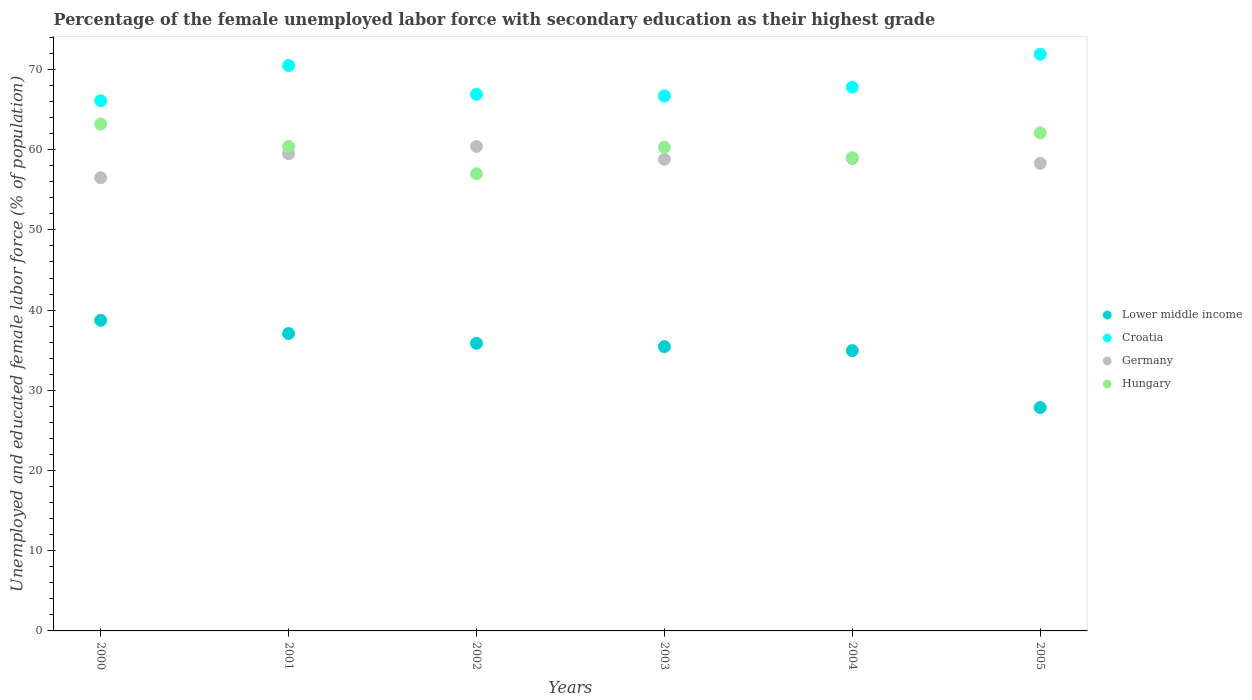How many different coloured dotlines are there?
Your answer should be very brief. 4. Is the number of dotlines equal to the number of legend labels?
Give a very brief answer. Yes. What is the percentage of the unemployed female labor force with secondary education in Hungary in 2002?
Ensure brevity in your answer.  57. Across all years, what is the maximum percentage of the unemployed female labor force with secondary education in Croatia?
Keep it short and to the point. 71.9. Across all years, what is the minimum percentage of the unemployed female labor force with secondary education in Lower middle income?
Your response must be concise. 27.85. What is the total percentage of the unemployed female labor force with secondary education in Germany in the graph?
Your answer should be compact. 352.4. What is the difference between the percentage of the unemployed female labor force with secondary education in Germany in 2001 and that in 2003?
Make the answer very short. 0.7. What is the difference between the percentage of the unemployed female labor force with secondary education in Lower middle income in 2004 and the percentage of the unemployed female labor force with secondary education in Germany in 2002?
Make the answer very short. -25.45. What is the average percentage of the unemployed female labor force with secondary education in Germany per year?
Ensure brevity in your answer.  58.73. In the year 2005, what is the difference between the percentage of the unemployed female labor force with secondary education in Croatia and percentage of the unemployed female labor force with secondary education in Germany?
Your response must be concise. 13.6. What is the ratio of the percentage of the unemployed female labor force with secondary education in Germany in 2001 to that in 2003?
Offer a terse response. 1.01. Is the difference between the percentage of the unemployed female labor force with secondary education in Croatia in 2003 and 2005 greater than the difference between the percentage of the unemployed female labor force with secondary education in Germany in 2003 and 2005?
Ensure brevity in your answer.  No. What is the difference between the highest and the second highest percentage of the unemployed female labor force with secondary education in Lower middle income?
Your answer should be compact. 1.64. What is the difference between the highest and the lowest percentage of the unemployed female labor force with secondary education in Lower middle income?
Provide a short and direct response. 10.87. Is the sum of the percentage of the unemployed female labor force with secondary education in Croatia in 2001 and 2005 greater than the maximum percentage of the unemployed female labor force with secondary education in Hungary across all years?
Your response must be concise. Yes. Is it the case that in every year, the sum of the percentage of the unemployed female labor force with secondary education in Lower middle income and percentage of the unemployed female labor force with secondary education in Germany  is greater than the sum of percentage of the unemployed female labor force with secondary education in Croatia and percentage of the unemployed female labor force with secondary education in Hungary?
Ensure brevity in your answer.  No. Is it the case that in every year, the sum of the percentage of the unemployed female labor force with secondary education in Hungary and percentage of the unemployed female labor force with secondary education in Germany  is greater than the percentage of the unemployed female labor force with secondary education in Croatia?
Offer a terse response. Yes. Does the percentage of the unemployed female labor force with secondary education in Germany monotonically increase over the years?
Provide a succinct answer. No. Is the percentage of the unemployed female labor force with secondary education in Hungary strictly less than the percentage of the unemployed female labor force with secondary education in Lower middle income over the years?
Your response must be concise. No. How many dotlines are there?
Keep it short and to the point. 4. How many years are there in the graph?
Keep it short and to the point. 6. Are the values on the major ticks of Y-axis written in scientific E-notation?
Your answer should be very brief. No. Does the graph contain grids?
Provide a succinct answer. No. What is the title of the graph?
Your answer should be very brief. Percentage of the female unemployed labor force with secondary education as their highest grade. What is the label or title of the Y-axis?
Your response must be concise. Unemployed and educated female labor force (% of population). What is the Unemployed and educated female labor force (% of population) in Lower middle income in 2000?
Provide a short and direct response. 38.72. What is the Unemployed and educated female labor force (% of population) in Croatia in 2000?
Your answer should be very brief. 66.1. What is the Unemployed and educated female labor force (% of population) in Germany in 2000?
Provide a succinct answer. 56.5. What is the Unemployed and educated female labor force (% of population) of Hungary in 2000?
Give a very brief answer. 63.2. What is the Unemployed and educated female labor force (% of population) in Lower middle income in 2001?
Keep it short and to the point. 37.08. What is the Unemployed and educated female labor force (% of population) of Croatia in 2001?
Ensure brevity in your answer.  70.5. What is the Unemployed and educated female labor force (% of population) of Germany in 2001?
Provide a succinct answer. 59.5. What is the Unemployed and educated female labor force (% of population) of Hungary in 2001?
Give a very brief answer. 60.4. What is the Unemployed and educated female labor force (% of population) of Lower middle income in 2002?
Your answer should be compact. 35.86. What is the Unemployed and educated female labor force (% of population) in Croatia in 2002?
Keep it short and to the point. 66.9. What is the Unemployed and educated female labor force (% of population) of Germany in 2002?
Keep it short and to the point. 60.4. What is the Unemployed and educated female labor force (% of population) of Lower middle income in 2003?
Provide a short and direct response. 35.45. What is the Unemployed and educated female labor force (% of population) of Croatia in 2003?
Your answer should be compact. 66.7. What is the Unemployed and educated female labor force (% of population) of Germany in 2003?
Your answer should be very brief. 58.8. What is the Unemployed and educated female labor force (% of population) of Hungary in 2003?
Your answer should be compact. 60.3. What is the Unemployed and educated female labor force (% of population) of Lower middle income in 2004?
Provide a short and direct response. 34.95. What is the Unemployed and educated female labor force (% of population) in Croatia in 2004?
Ensure brevity in your answer.  67.8. What is the Unemployed and educated female labor force (% of population) of Germany in 2004?
Provide a short and direct response. 58.9. What is the Unemployed and educated female labor force (% of population) in Hungary in 2004?
Your answer should be compact. 59. What is the Unemployed and educated female labor force (% of population) of Lower middle income in 2005?
Offer a very short reply. 27.85. What is the Unemployed and educated female labor force (% of population) in Croatia in 2005?
Offer a terse response. 71.9. What is the Unemployed and educated female labor force (% of population) of Germany in 2005?
Your answer should be compact. 58.3. What is the Unemployed and educated female labor force (% of population) of Hungary in 2005?
Ensure brevity in your answer.  62.1. Across all years, what is the maximum Unemployed and educated female labor force (% of population) of Lower middle income?
Provide a short and direct response. 38.72. Across all years, what is the maximum Unemployed and educated female labor force (% of population) of Croatia?
Your answer should be very brief. 71.9. Across all years, what is the maximum Unemployed and educated female labor force (% of population) in Germany?
Offer a terse response. 60.4. Across all years, what is the maximum Unemployed and educated female labor force (% of population) of Hungary?
Provide a short and direct response. 63.2. Across all years, what is the minimum Unemployed and educated female labor force (% of population) in Lower middle income?
Offer a very short reply. 27.85. Across all years, what is the minimum Unemployed and educated female labor force (% of population) in Croatia?
Your response must be concise. 66.1. Across all years, what is the minimum Unemployed and educated female labor force (% of population) in Germany?
Ensure brevity in your answer.  56.5. Across all years, what is the minimum Unemployed and educated female labor force (% of population) in Hungary?
Give a very brief answer. 57. What is the total Unemployed and educated female labor force (% of population) of Lower middle income in the graph?
Your answer should be very brief. 209.91. What is the total Unemployed and educated female labor force (% of population) of Croatia in the graph?
Your answer should be very brief. 409.9. What is the total Unemployed and educated female labor force (% of population) in Germany in the graph?
Keep it short and to the point. 352.4. What is the total Unemployed and educated female labor force (% of population) in Hungary in the graph?
Provide a succinct answer. 362. What is the difference between the Unemployed and educated female labor force (% of population) in Lower middle income in 2000 and that in 2001?
Provide a succinct answer. 1.64. What is the difference between the Unemployed and educated female labor force (% of population) of Croatia in 2000 and that in 2001?
Provide a succinct answer. -4.4. What is the difference between the Unemployed and educated female labor force (% of population) in Hungary in 2000 and that in 2001?
Keep it short and to the point. 2.8. What is the difference between the Unemployed and educated female labor force (% of population) of Lower middle income in 2000 and that in 2002?
Make the answer very short. 2.87. What is the difference between the Unemployed and educated female labor force (% of population) in Hungary in 2000 and that in 2002?
Provide a succinct answer. 6.2. What is the difference between the Unemployed and educated female labor force (% of population) of Lower middle income in 2000 and that in 2003?
Make the answer very short. 3.28. What is the difference between the Unemployed and educated female labor force (% of population) in Croatia in 2000 and that in 2003?
Your answer should be very brief. -0.6. What is the difference between the Unemployed and educated female labor force (% of population) of Germany in 2000 and that in 2003?
Offer a very short reply. -2.3. What is the difference between the Unemployed and educated female labor force (% of population) in Lower middle income in 2000 and that in 2004?
Keep it short and to the point. 3.77. What is the difference between the Unemployed and educated female labor force (% of population) in Croatia in 2000 and that in 2004?
Your answer should be compact. -1.7. What is the difference between the Unemployed and educated female labor force (% of population) in Lower middle income in 2000 and that in 2005?
Offer a terse response. 10.87. What is the difference between the Unemployed and educated female labor force (% of population) in Croatia in 2000 and that in 2005?
Ensure brevity in your answer.  -5.8. What is the difference between the Unemployed and educated female labor force (% of population) of Lower middle income in 2001 and that in 2002?
Your answer should be very brief. 1.22. What is the difference between the Unemployed and educated female labor force (% of population) in Croatia in 2001 and that in 2002?
Give a very brief answer. 3.6. What is the difference between the Unemployed and educated female labor force (% of population) of Germany in 2001 and that in 2002?
Keep it short and to the point. -0.9. What is the difference between the Unemployed and educated female labor force (% of population) of Lower middle income in 2001 and that in 2003?
Ensure brevity in your answer.  1.64. What is the difference between the Unemployed and educated female labor force (% of population) of Germany in 2001 and that in 2003?
Provide a short and direct response. 0.7. What is the difference between the Unemployed and educated female labor force (% of population) in Hungary in 2001 and that in 2003?
Provide a short and direct response. 0.1. What is the difference between the Unemployed and educated female labor force (% of population) in Lower middle income in 2001 and that in 2004?
Offer a very short reply. 2.13. What is the difference between the Unemployed and educated female labor force (% of population) in Hungary in 2001 and that in 2004?
Offer a terse response. 1.4. What is the difference between the Unemployed and educated female labor force (% of population) of Lower middle income in 2001 and that in 2005?
Ensure brevity in your answer.  9.23. What is the difference between the Unemployed and educated female labor force (% of population) in Croatia in 2001 and that in 2005?
Your answer should be compact. -1.4. What is the difference between the Unemployed and educated female labor force (% of population) of Germany in 2001 and that in 2005?
Make the answer very short. 1.2. What is the difference between the Unemployed and educated female labor force (% of population) in Lower middle income in 2002 and that in 2003?
Provide a succinct answer. 0.41. What is the difference between the Unemployed and educated female labor force (% of population) in Hungary in 2002 and that in 2003?
Your answer should be compact. -3.3. What is the difference between the Unemployed and educated female labor force (% of population) of Lower middle income in 2002 and that in 2004?
Provide a short and direct response. 0.91. What is the difference between the Unemployed and educated female labor force (% of population) of Germany in 2002 and that in 2004?
Make the answer very short. 1.5. What is the difference between the Unemployed and educated female labor force (% of population) of Hungary in 2002 and that in 2004?
Your response must be concise. -2. What is the difference between the Unemployed and educated female labor force (% of population) of Lower middle income in 2002 and that in 2005?
Provide a short and direct response. 8.01. What is the difference between the Unemployed and educated female labor force (% of population) in Croatia in 2002 and that in 2005?
Provide a succinct answer. -5. What is the difference between the Unemployed and educated female labor force (% of population) of Lower middle income in 2003 and that in 2004?
Make the answer very short. 0.5. What is the difference between the Unemployed and educated female labor force (% of population) of Germany in 2003 and that in 2004?
Your answer should be compact. -0.1. What is the difference between the Unemployed and educated female labor force (% of population) of Lower middle income in 2003 and that in 2005?
Give a very brief answer. 7.6. What is the difference between the Unemployed and educated female labor force (% of population) of Croatia in 2003 and that in 2005?
Keep it short and to the point. -5.2. What is the difference between the Unemployed and educated female labor force (% of population) in Germany in 2003 and that in 2005?
Keep it short and to the point. 0.5. What is the difference between the Unemployed and educated female labor force (% of population) of Lower middle income in 2004 and that in 2005?
Give a very brief answer. 7.1. What is the difference between the Unemployed and educated female labor force (% of population) of Croatia in 2004 and that in 2005?
Offer a terse response. -4.1. What is the difference between the Unemployed and educated female labor force (% of population) of Lower middle income in 2000 and the Unemployed and educated female labor force (% of population) of Croatia in 2001?
Provide a succinct answer. -31.78. What is the difference between the Unemployed and educated female labor force (% of population) of Lower middle income in 2000 and the Unemployed and educated female labor force (% of population) of Germany in 2001?
Offer a terse response. -20.78. What is the difference between the Unemployed and educated female labor force (% of population) in Lower middle income in 2000 and the Unemployed and educated female labor force (% of population) in Hungary in 2001?
Provide a short and direct response. -21.68. What is the difference between the Unemployed and educated female labor force (% of population) in Germany in 2000 and the Unemployed and educated female labor force (% of population) in Hungary in 2001?
Offer a terse response. -3.9. What is the difference between the Unemployed and educated female labor force (% of population) in Lower middle income in 2000 and the Unemployed and educated female labor force (% of population) in Croatia in 2002?
Your answer should be very brief. -28.18. What is the difference between the Unemployed and educated female labor force (% of population) in Lower middle income in 2000 and the Unemployed and educated female labor force (% of population) in Germany in 2002?
Provide a short and direct response. -21.68. What is the difference between the Unemployed and educated female labor force (% of population) in Lower middle income in 2000 and the Unemployed and educated female labor force (% of population) in Hungary in 2002?
Your answer should be compact. -18.28. What is the difference between the Unemployed and educated female labor force (% of population) in Croatia in 2000 and the Unemployed and educated female labor force (% of population) in Germany in 2002?
Give a very brief answer. 5.7. What is the difference between the Unemployed and educated female labor force (% of population) of Germany in 2000 and the Unemployed and educated female labor force (% of population) of Hungary in 2002?
Keep it short and to the point. -0.5. What is the difference between the Unemployed and educated female labor force (% of population) of Lower middle income in 2000 and the Unemployed and educated female labor force (% of population) of Croatia in 2003?
Give a very brief answer. -27.98. What is the difference between the Unemployed and educated female labor force (% of population) of Lower middle income in 2000 and the Unemployed and educated female labor force (% of population) of Germany in 2003?
Give a very brief answer. -20.08. What is the difference between the Unemployed and educated female labor force (% of population) in Lower middle income in 2000 and the Unemployed and educated female labor force (% of population) in Hungary in 2003?
Ensure brevity in your answer.  -21.58. What is the difference between the Unemployed and educated female labor force (% of population) of Croatia in 2000 and the Unemployed and educated female labor force (% of population) of Germany in 2003?
Your response must be concise. 7.3. What is the difference between the Unemployed and educated female labor force (% of population) in Croatia in 2000 and the Unemployed and educated female labor force (% of population) in Hungary in 2003?
Offer a terse response. 5.8. What is the difference between the Unemployed and educated female labor force (% of population) of Lower middle income in 2000 and the Unemployed and educated female labor force (% of population) of Croatia in 2004?
Ensure brevity in your answer.  -29.08. What is the difference between the Unemployed and educated female labor force (% of population) in Lower middle income in 2000 and the Unemployed and educated female labor force (% of population) in Germany in 2004?
Your answer should be very brief. -20.18. What is the difference between the Unemployed and educated female labor force (% of population) of Lower middle income in 2000 and the Unemployed and educated female labor force (% of population) of Hungary in 2004?
Give a very brief answer. -20.28. What is the difference between the Unemployed and educated female labor force (% of population) in Germany in 2000 and the Unemployed and educated female labor force (% of population) in Hungary in 2004?
Provide a short and direct response. -2.5. What is the difference between the Unemployed and educated female labor force (% of population) of Lower middle income in 2000 and the Unemployed and educated female labor force (% of population) of Croatia in 2005?
Make the answer very short. -33.18. What is the difference between the Unemployed and educated female labor force (% of population) of Lower middle income in 2000 and the Unemployed and educated female labor force (% of population) of Germany in 2005?
Ensure brevity in your answer.  -19.58. What is the difference between the Unemployed and educated female labor force (% of population) of Lower middle income in 2000 and the Unemployed and educated female labor force (% of population) of Hungary in 2005?
Offer a very short reply. -23.38. What is the difference between the Unemployed and educated female labor force (% of population) of Croatia in 2000 and the Unemployed and educated female labor force (% of population) of Hungary in 2005?
Your answer should be compact. 4. What is the difference between the Unemployed and educated female labor force (% of population) of Germany in 2000 and the Unemployed and educated female labor force (% of population) of Hungary in 2005?
Keep it short and to the point. -5.6. What is the difference between the Unemployed and educated female labor force (% of population) of Lower middle income in 2001 and the Unemployed and educated female labor force (% of population) of Croatia in 2002?
Offer a terse response. -29.82. What is the difference between the Unemployed and educated female labor force (% of population) in Lower middle income in 2001 and the Unemployed and educated female labor force (% of population) in Germany in 2002?
Your response must be concise. -23.32. What is the difference between the Unemployed and educated female labor force (% of population) in Lower middle income in 2001 and the Unemployed and educated female labor force (% of population) in Hungary in 2002?
Offer a very short reply. -19.92. What is the difference between the Unemployed and educated female labor force (% of population) in Croatia in 2001 and the Unemployed and educated female labor force (% of population) in Germany in 2002?
Offer a terse response. 10.1. What is the difference between the Unemployed and educated female labor force (% of population) of Lower middle income in 2001 and the Unemployed and educated female labor force (% of population) of Croatia in 2003?
Provide a succinct answer. -29.62. What is the difference between the Unemployed and educated female labor force (% of population) of Lower middle income in 2001 and the Unemployed and educated female labor force (% of population) of Germany in 2003?
Provide a short and direct response. -21.72. What is the difference between the Unemployed and educated female labor force (% of population) in Lower middle income in 2001 and the Unemployed and educated female labor force (% of population) in Hungary in 2003?
Provide a succinct answer. -23.22. What is the difference between the Unemployed and educated female labor force (% of population) in Croatia in 2001 and the Unemployed and educated female labor force (% of population) in Germany in 2003?
Give a very brief answer. 11.7. What is the difference between the Unemployed and educated female labor force (% of population) in Lower middle income in 2001 and the Unemployed and educated female labor force (% of population) in Croatia in 2004?
Your response must be concise. -30.72. What is the difference between the Unemployed and educated female labor force (% of population) of Lower middle income in 2001 and the Unemployed and educated female labor force (% of population) of Germany in 2004?
Offer a very short reply. -21.82. What is the difference between the Unemployed and educated female labor force (% of population) in Lower middle income in 2001 and the Unemployed and educated female labor force (% of population) in Hungary in 2004?
Make the answer very short. -21.92. What is the difference between the Unemployed and educated female labor force (% of population) of Croatia in 2001 and the Unemployed and educated female labor force (% of population) of Hungary in 2004?
Your answer should be very brief. 11.5. What is the difference between the Unemployed and educated female labor force (% of population) in Germany in 2001 and the Unemployed and educated female labor force (% of population) in Hungary in 2004?
Keep it short and to the point. 0.5. What is the difference between the Unemployed and educated female labor force (% of population) of Lower middle income in 2001 and the Unemployed and educated female labor force (% of population) of Croatia in 2005?
Your answer should be compact. -34.82. What is the difference between the Unemployed and educated female labor force (% of population) in Lower middle income in 2001 and the Unemployed and educated female labor force (% of population) in Germany in 2005?
Provide a short and direct response. -21.22. What is the difference between the Unemployed and educated female labor force (% of population) in Lower middle income in 2001 and the Unemployed and educated female labor force (% of population) in Hungary in 2005?
Offer a very short reply. -25.02. What is the difference between the Unemployed and educated female labor force (% of population) in Croatia in 2001 and the Unemployed and educated female labor force (% of population) in Hungary in 2005?
Ensure brevity in your answer.  8.4. What is the difference between the Unemployed and educated female labor force (% of population) in Germany in 2001 and the Unemployed and educated female labor force (% of population) in Hungary in 2005?
Ensure brevity in your answer.  -2.6. What is the difference between the Unemployed and educated female labor force (% of population) in Lower middle income in 2002 and the Unemployed and educated female labor force (% of population) in Croatia in 2003?
Keep it short and to the point. -30.84. What is the difference between the Unemployed and educated female labor force (% of population) of Lower middle income in 2002 and the Unemployed and educated female labor force (% of population) of Germany in 2003?
Provide a short and direct response. -22.94. What is the difference between the Unemployed and educated female labor force (% of population) of Lower middle income in 2002 and the Unemployed and educated female labor force (% of population) of Hungary in 2003?
Offer a terse response. -24.44. What is the difference between the Unemployed and educated female labor force (% of population) of Croatia in 2002 and the Unemployed and educated female labor force (% of population) of Hungary in 2003?
Give a very brief answer. 6.6. What is the difference between the Unemployed and educated female labor force (% of population) of Germany in 2002 and the Unemployed and educated female labor force (% of population) of Hungary in 2003?
Your answer should be very brief. 0.1. What is the difference between the Unemployed and educated female labor force (% of population) of Lower middle income in 2002 and the Unemployed and educated female labor force (% of population) of Croatia in 2004?
Give a very brief answer. -31.94. What is the difference between the Unemployed and educated female labor force (% of population) of Lower middle income in 2002 and the Unemployed and educated female labor force (% of population) of Germany in 2004?
Offer a very short reply. -23.04. What is the difference between the Unemployed and educated female labor force (% of population) of Lower middle income in 2002 and the Unemployed and educated female labor force (% of population) of Hungary in 2004?
Ensure brevity in your answer.  -23.14. What is the difference between the Unemployed and educated female labor force (% of population) of Croatia in 2002 and the Unemployed and educated female labor force (% of population) of Germany in 2004?
Keep it short and to the point. 8. What is the difference between the Unemployed and educated female labor force (% of population) in Lower middle income in 2002 and the Unemployed and educated female labor force (% of population) in Croatia in 2005?
Your response must be concise. -36.04. What is the difference between the Unemployed and educated female labor force (% of population) in Lower middle income in 2002 and the Unemployed and educated female labor force (% of population) in Germany in 2005?
Provide a succinct answer. -22.44. What is the difference between the Unemployed and educated female labor force (% of population) in Lower middle income in 2002 and the Unemployed and educated female labor force (% of population) in Hungary in 2005?
Your answer should be compact. -26.24. What is the difference between the Unemployed and educated female labor force (% of population) in Croatia in 2002 and the Unemployed and educated female labor force (% of population) in Hungary in 2005?
Your answer should be compact. 4.8. What is the difference between the Unemployed and educated female labor force (% of population) of Lower middle income in 2003 and the Unemployed and educated female labor force (% of population) of Croatia in 2004?
Ensure brevity in your answer.  -32.35. What is the difference between the Unemployed and educated female labor force (% of population) in Lower middle income in 2003 and the Unemployed and educated female labor force (% of population) in Germany in 2004?
Your answer should be compact. -23.45. What is the difference between the Unemployed and educated female labor force (% of population) in Lower middle income in 2003 and the Unemployed and educated female labor force (% of population) in Hungary in 2004?
Your response must be concise. -23.55. What is the difference between the Unemployed and educated female labor force (% of population) of Croatia in 2003 and the Unemployed and educated female labor force (% of population) of Germany in 2004?
Ensure brevity in your answer.  7.8. What is the difference between the Unemployed and educated female labor force (% of population) of Lower middle income in 2003 and the Unemployed and educated female labor force (% of population) of Croatia in 2005?
Your answer should be very brief. -36.45. What is the difference between the Unemployed and educated female labor force (% of population) of Lower middle income in 2003 and the Unemployed and educated female labor force (% of population) of Germany in 2005?
Provide a succinct answer. -22.85. What is the difference between the Unemployed and educated female labor force (% of population) of Lower middle income in 2003 and the Unemployed and educated female labor force (% of population) of Hungary in 2005?
Your answer should be compact. -26.65. What is the difference between the Unemployed and educated female labor force (% of population) of Croatia in 2003 and the Unemployed and educated female labor force (% of population) of Germany in 2005?
Offer a very short reply. 8.4. What is the difference between the Unemployed and educated female labor force (% of population) in Germany in 2003 and the Unemployed and educated female labor force (% of population) in Hungary in 2005?
Offer a terse response. -3.3. What is the difference between the Unemployed and educated female labor force (% of population) in Lower middle income in 2004 and the Unemployed and educated female labor force (% of population) in Croatia in 2005?
Provide a short and direct response. -36.95. What is the difference between the Unemployed and educated female labor force (% of population) of Lower middle income in 2004 and the Unemployed and educated female labor force (% of population) of Germany in 2005?
Provide a short and direct response. -23.35. What is the difference between the Unemployed and educated female labor force (% of population) in Lower middle income in 2004 and the Unemployed and educated female labor force (% of population) in Hungary in 2005?
Your answer should be very brief. -27.15. What is the difference between the Unemployed and educated female labor force (% of population) in Croatia in 2004 and the Unemployed and educated female labor force (% of population) in Hungary in 2005?
Offer a terse response. 5.7. What is the difference between the Unemployed and educated female labor force (% of population) in Germany in 2004 and the Unemployed and educated female labor force (% of population) in Hungary in 2005?
Ensure brevity in your answer.  -3.2. What is the average Unemployed and educated female labor force (% of population) of Lower middle income per year?
Ensure brevity in your answer.  34.98. What is the average Unemployed and educated female labor force (% of population) of Croatia per year?
Give a very brief answer. 68.32. What is the average Unemployed and educated female labor force (% of population) in Germany per year?
Offer a very short reply. 58.73. What is the average Unemployed and educated female labor force (% of population) of Hungary per year?
Your response must be concise. 60.33. In the year 2000, what is the difference between the Unemployed and educated female labor force (% of population) of Lower middle income and Unemployed and educated female labor force (% of population) of Croatia?
Offer a very short reply. -27.38. In the year 2000, what is the difference between the Unemployed and educated female labor force (% of population) in Lower middle income and Unemployed and educated female labor force (% of population) in Germany?
Provide a short and direct response. -17.78. In the year 2000, what is the difference between the Unemployed and educated female labor force (% of population) of Lower middle income and Unemployed and educated female labor force (% of population) of Hungary?
Your answer should be very brief. -24.48. In the year 2000, what is the difference between the Unemployed and educated female labor force (% of population) in Germany and Unemployed and educated female labor force (% of population) in Hungary?
Give a very brief answer. -6.7. In the year 2001, what is the difference between the Unemployed and educated female labor force (% of population) of Lower middle income and Unemployed and educated female labor force (% of population) of Croatia?
Give a very brief answer. -33.42. In the year 2001, what is the difference between the Unemployed and educated female labor force (% of population) of Lower middle income and Unemployed and educated female labor force (% of population) of Germany?
Make the answer very short. -22.42. In the year 2001, what is the difference between the Unemployed and educated female labor force (% of population) in Lower middle income and Unemployed and educated female labor force (% of population) in Hungary?
Give a very brief answer. -23.32. In the year 2001, what is the difference between the Unemployed and educated female labor force (% of population) of Croatia and Unemployed and educated female labor force (% of population) of Germany?
Make the answer very short. 11. In the year 2002, what is the difference between the Unemployed and educated female labor force (% of population) in Lower middle income and Unemployed and educated female labor force (% of population) in Croatia?
Keep it short and to the point. -31.04. In the year 2002, what is the difference between the Unemployed and educated female labor force (% of population) in Lower middle income and Unemployed and educated female labor force (% of population) in Germany?
Your response must be concise. -24.54. In the year 2002, what is the difference between the Unemployed and educated female labor force (% of population) in Lower middle income and Unemployed and educated female labor force (% of population) in Hungary?
Your response must be concise. -21.14. In the year 2002, what is the difference between the Unemployed and educated female labor force (% of population) of Croatia and Unemployed and educated female labor force (% of population) of Germany?
Offer a very short reply. 6.5. In the year 2002, what is the difference between the Unemployed and educated female labor force (% of population) of Germany and Unemployed and educated female labor force (% of population) of Hungary?
Give a very brief answer. 3.4. In the year 2003, what is the difference between the Unemployed and educated female labor force (% of population) of Lower middle income and Unemployed and educated female labor force (% of population) of Croatia?
Offer a very short reply. -31.25. In the year 2003, what is the difference between the Unemployed and educated female labor force (% of population) in Lower middle income and Unemployed and educated female labor force (% of population) in Germany?
Your response must be concise. -23.35. In the year 2003, what is the difference between the Unemployed and educated female labor force (% of population) of Lower middle income and Unemployed and educated female labor force (% of population) of Hungary?
Give a very brief answer. -24.85. In the year 2003, what is the difference between the Unemployed and educated female labor force (% of population) of Croatia and Unemployed and educated female labor force (% of population) of Germany?
Make the answer very short. 7.9. In the year 2004, what is the difference between the Unemployed and educated female labor force (% of population) of Lower middle income and Unemployed and educated female labor force (% of population) of Croatia?
Provide a succinct answer. -32.85. In the year 2004, what is the difference between the Unemployed and educated female labor force (% of population) of Lower middle income and Unemployed and educated female labor force (% of population) of Germany?
Give a very brief answer. -23.95. In the year 2004, what is the difference between the Unemployed and educated female labor force (% of population) of Lower middle income and Unemployed and educated female labor force (% of population) of Hungary?
Your response must be concise. -24.05. In the year 2004, what is the difference between the Unemployed and educated female labor force (% of population) of Croatia and Unemployed and educated female labor force (% of population) of Hungary?
Your answer should be very brief. 8.8. In the year 2005, what is the difference between the Unemployed and educated female labor force (% of population) in Lower middle income and Unemployed and educated female labor force (% of population) in Croatia?
Provide a short and direct response. -44.05. In the year 2005, what is the difference between the Unemployed and educated female labor force (% of population) in Lower middle income and Unemployed and educated female labor force (% of population) in Germany?
Keep it short and to the point. -30.45. In the year 2005, what is the difference between the Unemployed and educated female labor force (% of population) in Lower middle income and Unemployed and educated female labor force (% of population) in Hungary?
Offer a very short reply. -34.25. In the year 2005, what is the difference between the Unemployed and educated female labor force (% of population) of Croatia and Unemployed and educated female labor force (% of population) of Hungary?
Make the answer very short. 9.8. In the year 2005, what is the difference between the Unemployed and educated female labor force (% of population) in Germany and Unemployed and educated female labor force (% of population) in Hungary?
Your response must be concise. -3.8. What is the ratio of the Unemployed and educated female labor force (% of population) in Lower middle income in 2000 to that in 2001?
Offer a terse response. 1.04. What is the ratio of the Unemployed and educated female labor force (% of population) of Croatia in 2000 to that in 2001?
Give a very brief answer. 0.94. What is the ratio of the Unemployed and educated female labor force (% of population) of Germany in 2000 to that in 2001?
Offer a terse response. 0.95. What is the ratio of the Unemployed and educated female labor force (% of population) of Hungary in 2000 to that in 2001?
Your answer should be very brief. 1.05. What is the ratio of the Unemployed and educated female labor force (% of population) in Lower middle income in 2000 to that in 2002?
Offer a very short reply. 1.08. What is the ratio of the Unemployed and educated female labor force (% of population) in Croatia in 2000 to that in 2002?
Offer a very short reply. 0.99. What is the ratio of the Unemployed and educated female labor force (% of population) in Germany in 2000 to that in 2002?
Make the answer very short. 0.94. What is the ratio of the Unemployed and educated female labor force (% of population) in Hungary in 2000 to that in 2002?
Offer a terse response. 1.11. What is the ratio of the Unemployed and educated female labor force (% of population) of Lower middle income in 2000 to that in 2003?
Offer a terse response. 1.09. What is the ratio of the Unemployed and educated female labor force (% of population) in Germany in 2000 to that in 2003?
Offer a very short reply. 0.96. What is the ratio of the Unemployed and educated female labor force (% of population) in Hungary in 2000 to that in 2003?
Your response must be concise. 1.05. What is the ratio of the Unemployed and educated female labor force (% of population) in Lower middle income in 2000 to that in 2004?
Your answer should be compact. 1.11. What is the ratio of the Unemployed and educated female labor force (% of population) in Croatia in 2000 to that in 2004?
Provide a succinct answer. 0.97. What is the ratio of the Unemployed and educated female labor force (% of population) in Germany in 2000 to that in 2004?
Offer a terse response. 0.96. What is the ratio of the Unemployed and educated female labor force (% of population) of Hungary in 2000 to that in 2004?
Your response must be concise. 1.07. What is the ratio of the Unemployed and educated female labor force (% of population) of Lower middle income in 2000 to that in 2005?
Ensure brevity in your answer.  1.39. What is the ratio of the Unemployed and educated female labor force (% of population) in Croatia in 2000 to that in 2005?
Ensure brevity in your answer.  0.92. What is the ratio of the Unemployed and educated female labor force (% of population) in Germany in 2000 to that in 2005?
Your answer should be compact. 0.97. What is the ratio of the Unemployed and educated female labor force (% of population) in Hungary in 2000 to that in 2005?
Your answer should be very brief. 1.02. What is the ratio of the Unemployed and educated female labor force (% of population) in Lower middle income in 2001 to that in 2002?
Give a very brief answer. 1.03. What is the ratio of the Unemployed and educated female labor force (% of population) of Croatia in 2001 to that in 2002?
Your answer should be very brief. 1.05. What is the ratio of the Unemployed and educated female labor force (% of population) of Germany in 2001 to that in 2002?
Your response must be concise. 0.99. What is the ratio of the Unemployed and educated female labor force (% of population) of Hungary in 2001 to that in 2002?
Your answer should be very brief. 1.06. What is the ratio of the Unemployed and educated female labor force (% of population) in Lower middle income in 2001 to that in 2003?
Provide a short and direct response. 1.05. What is the ratio of the Unemployed and educated female labor force (% of population) of Croatia in 2001 to that in 2003?
Make the answer very short. 1.06. What is the ratio of the Unemployed and educated female labor force (% of population) of Germany in 2001 to that in 2003?
Provide a succinct answer. 1.01. What is the ratio of the Unemployed and educated female labor force (% of population) of Lower middle income in 2001 to that in 2004?
Your answer should be very brief. 1.06. What is the ratio of the Unemployed and educated female labor force (% of population) in Croatia in 2001 to that in 2004?
Your answer should be compact. 1.04. What is the ratio of the Unemployed and educated female labor force (% of population) of Germany in 2001 to that in 2004?
Make the answer very short. 1.01. What is the ratio of the Unemployed and educated female labor force (% of population) of Hungary in 2001 to that in 2004?
Offer a very short reply. 1.02. What is the ratio of the Unemployed and educated female labor force (% of population) of Lower middle income in 2001 to that in 2005?
Your answer should be compact. 1.33. What is the ratio of the Unemployed and educated female labor force (% of population) of Croatia in 2001 to that in 2005?
Make the answer very short. 0.98. What is the ratio of the Unemployed and educated female labor force (% of population) of Germany in 2001 to that in 2005?
Your answer should be very brief. 1.02. What is the ratio of the Unemployed and educated female labor force (% of population) of Hungary in 2001 to that in 2005?
Give a very brief answer. 0.97. What is the ratio of the Unemployed and educated female labor force (% of population) of Lower middle income in 2002 to that in 2003?
Offer a very short reply. 1.01. What is the ratio of the Unemployed and educated female labor force (% of population) of Germany in 2002 to that in 2003?
Keep it short and to the point. 1.03. What is the ratio of the Unemployed and educated female labor force (% of population) in Hungary in 2002 to that in 2003?
Offer a very short reply. 0.95. What is the ratio of the Unemployed and educated female labor force (% of population) in Lower middle income in 2002 to that in 2004?
Offer a terse response. 1.03. What is the ratio of the Unemployed and educated female labor force (% of population) in Croatia in 2002 to that in 2004?
Your answer should be very brief. 0.99. What is the ratio of the Unemployed and educated female labor force (% of population) of Germany in 2002 to that in 2004?
Offer a terse response. 1.03. What is the ratio of the Unemployed and educated female labor force (% of population) in Hungary in 2002 to that in 2004?
Your answer should be very brief. 0.97. What is the ratio of the Unemployed and educated female labor force (% of population) of Lower middle income in 2002 to that in 2005?
Provide a succinct answer. 1.29. What is the ratio of the Unemployed and educated female labor force (% of population) of Croatia in 2002 to that in 2005?
Your answer should be compact. 0.93. What is the ratio of the Unemployed and educated female labor force (% of population) in Germany in 2002 to that in 2005?
Make the answer very short. 1.04. What is the ratio of the Unemployed and educated female labor force (% of population) of Hungary in 2002 to that in 2005?
Make the answer very short. 0.92. What is the ratio of the Unemployed and educated female labor force (% of population) in Lower middle income in 2003 to that in 2004?
Your answer should be compact. 1.01. What is the ratio of the Unemployed and educated female labor force (% of population) of Croatia in 2003 to that in 2004?
Give a very brief answer. 0.98. What is the ratio of the Unemployed and educated female labor force (% of population) in Germany in 2003 to that in 2004?
Provide a short and direct response. 1. What is the ratio of the Unemployed and educated female labor force (% of population) of Hungary in 2003 to that in 2004?
Offer a very short reply. 1.02. What is the ratio of the Unemployed and educated female labor force (% of population) in Lower middle income in 2003 to that in 2005?
Provide a succinct answer. 1.27. What is the ratio of the Unemployed and educated female labor force (% of population) of Croatia in 2003 to that in 2005?
Give a very brief answer. 0.93. What is the ratio of the Unemployed and educated female labor force (% of population) in Germany in 2003 to that in 2005?
Give a very brief answer. 1.01. What is the ratio of the Unemployed and educated female labor force (% of population) of Hungary in 2003 to that in 2005?
Keep it short and to the point. 0.97. What is the ratio of the Unemployed and educated female labor force (% of population) in Lower middle income in 2004 to that in 2005?
Give a very brief answer. 1.25. What is the ratio of the Unemployed and educated female labor force (% of population) in Croatia in 2004 to that in 2005?
Provide a succinct answer. 0.94. What is the ratio of the Unemployed and educated female labor force (% of population) of Germany in 2004 to that in 2005?
Your response must be concise. 1.01. What is the ratio of the Unemployed and educated female labor force (% of population) of Hungary in 2004 to that in 2005?
Your response must be concise. 0.95. What is the difference between the highest and the second highest Unemployed and educated female labor force (% of population) in Lower middle income?
Keep it short and to the point. 1.64. What is the difference between the highest and the second highest Unemployed and educated female labor force (% of population) of Hungary?
Your answer should be compact. 1.1. What is the difference between the highest and the lowest Unemployed and educated female labor force (% of population) in Lower middle income?
Provide a short and direct response. 10.87. What is the difference between the highest and the lowest Unemployed and educated female labor force (% of population) of Germany?
Your answer should be very brief. 3.9. What is the difference between the highest and the lowest Unemployed and educated female labor force (% of population) in Hungary?
Provide a short and direct response. 6.2. 